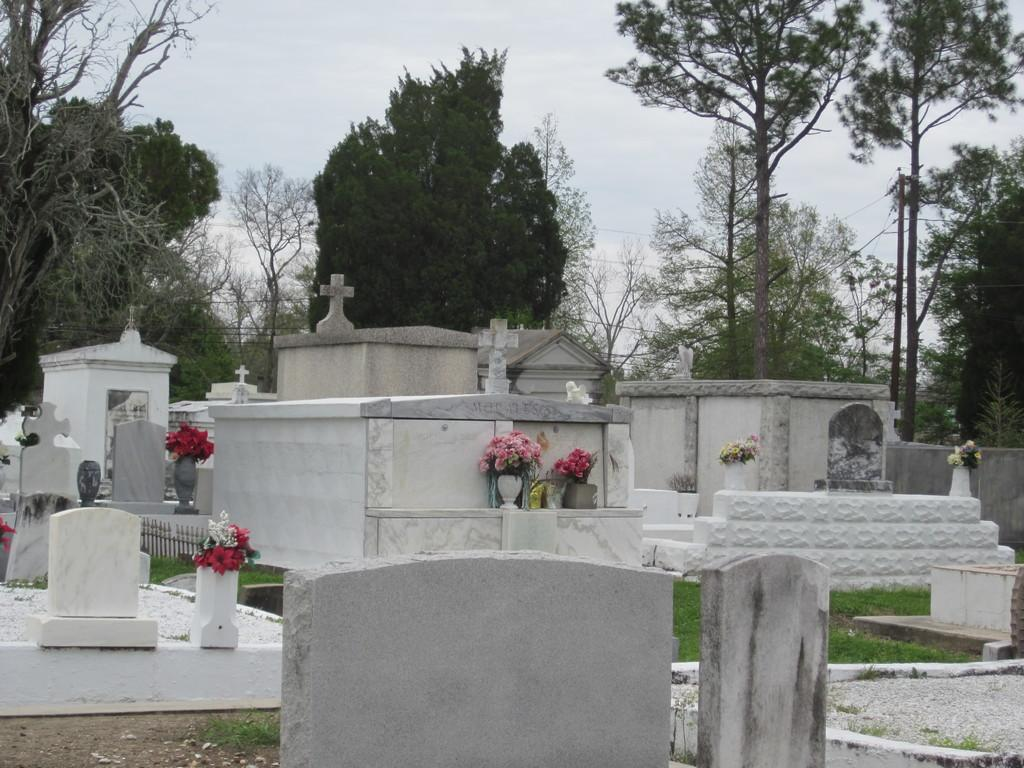What type of location is depicted in the image? The image depicts a graveyard. What type of vegetation can be seen in the graveyard? There is grass, plants with flowers, and trees in the graveyard. What is visible in the background of the image? The sky is visible in the background of the image. Can you see a nest in any of the trees in the image? There is no nest visible in any of the trees in the image. What type of amusement can be seen in the graveyard? There is no amusement present in the graveyard; it is a solemn location for burial and remembrance. 